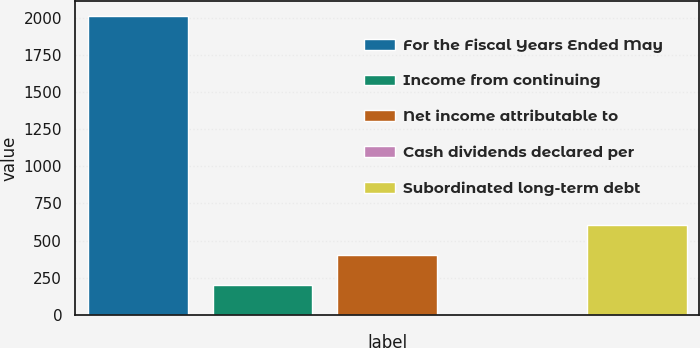<chart> <loc_0><loc_0><loc_500><loc_500><bar_chart><fcel>For the Fiscal Years Ended May<fcel>Income from continuing<fcel>Net income attributable to<fcel>Cash dividends declared per<fcel>Subordinated long-term debt<nl><fcel>2009<fcel>201.58<fcel>402.4<fcel>0.76<fcel>603.22<nl></chart> 